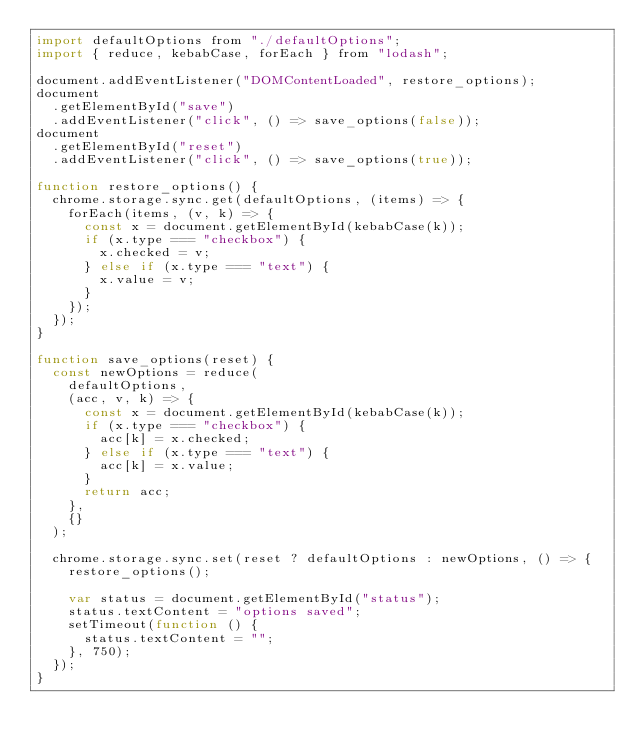Convert code to text. <code><loc_0><loc_0><loc_500><loc_500><_JavaScript_>import defaultOptions from "./defaultOptions";
import { reduce, kebabCase, forEach } from "lodash";

document.addEventListener("DOMContentLoaded", restore_options);
document
  .getElementById("save")
  .addEventListener("click", () => save_options(false));
document
  .getElementById("reset")
  .addEventListener("click", () => save_options(true));

function restore_options() {
  chrome.storage.sync.get(defaultOptions, (items) => {
    forEach(items, (v, k) => {
      const x = document.getElementById(kebabCase(k));
      if (x.type === "checkbox") {
        x.checked = v;
      } else if (x.type === "text") {
        x.value = v;
      }
    });
  });
}

function save_options(reset) {
  const newOptions = reduce(
    defaultOptions,
    (acc, v, k) => {
      const x = document.getElementById(kebabCase(k));
      if (x.type === "checkbox") {
        acc[k] = x.checked;
      } else if (x.type === "text") {
        acc[k] = x.value;
      }
      return acc;
    },
    {}
  );

  chrome.storage.sync.set(reset ? defaultOptions : newOptions, () => {
    restore_options();

    var status = document.getElementById("status");
    status.textContent = "options saved";
    setTimeout(function () {
      status.textContent = "";
    }, 750);
  });
}
</code> 